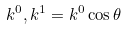Convert formula to latex. <formula><loc_0><loc_0><loc_500><loc_500>k ^ { 0 } , k ^ { 1 } = k ^ { 0 } \cos \theta</formula> 